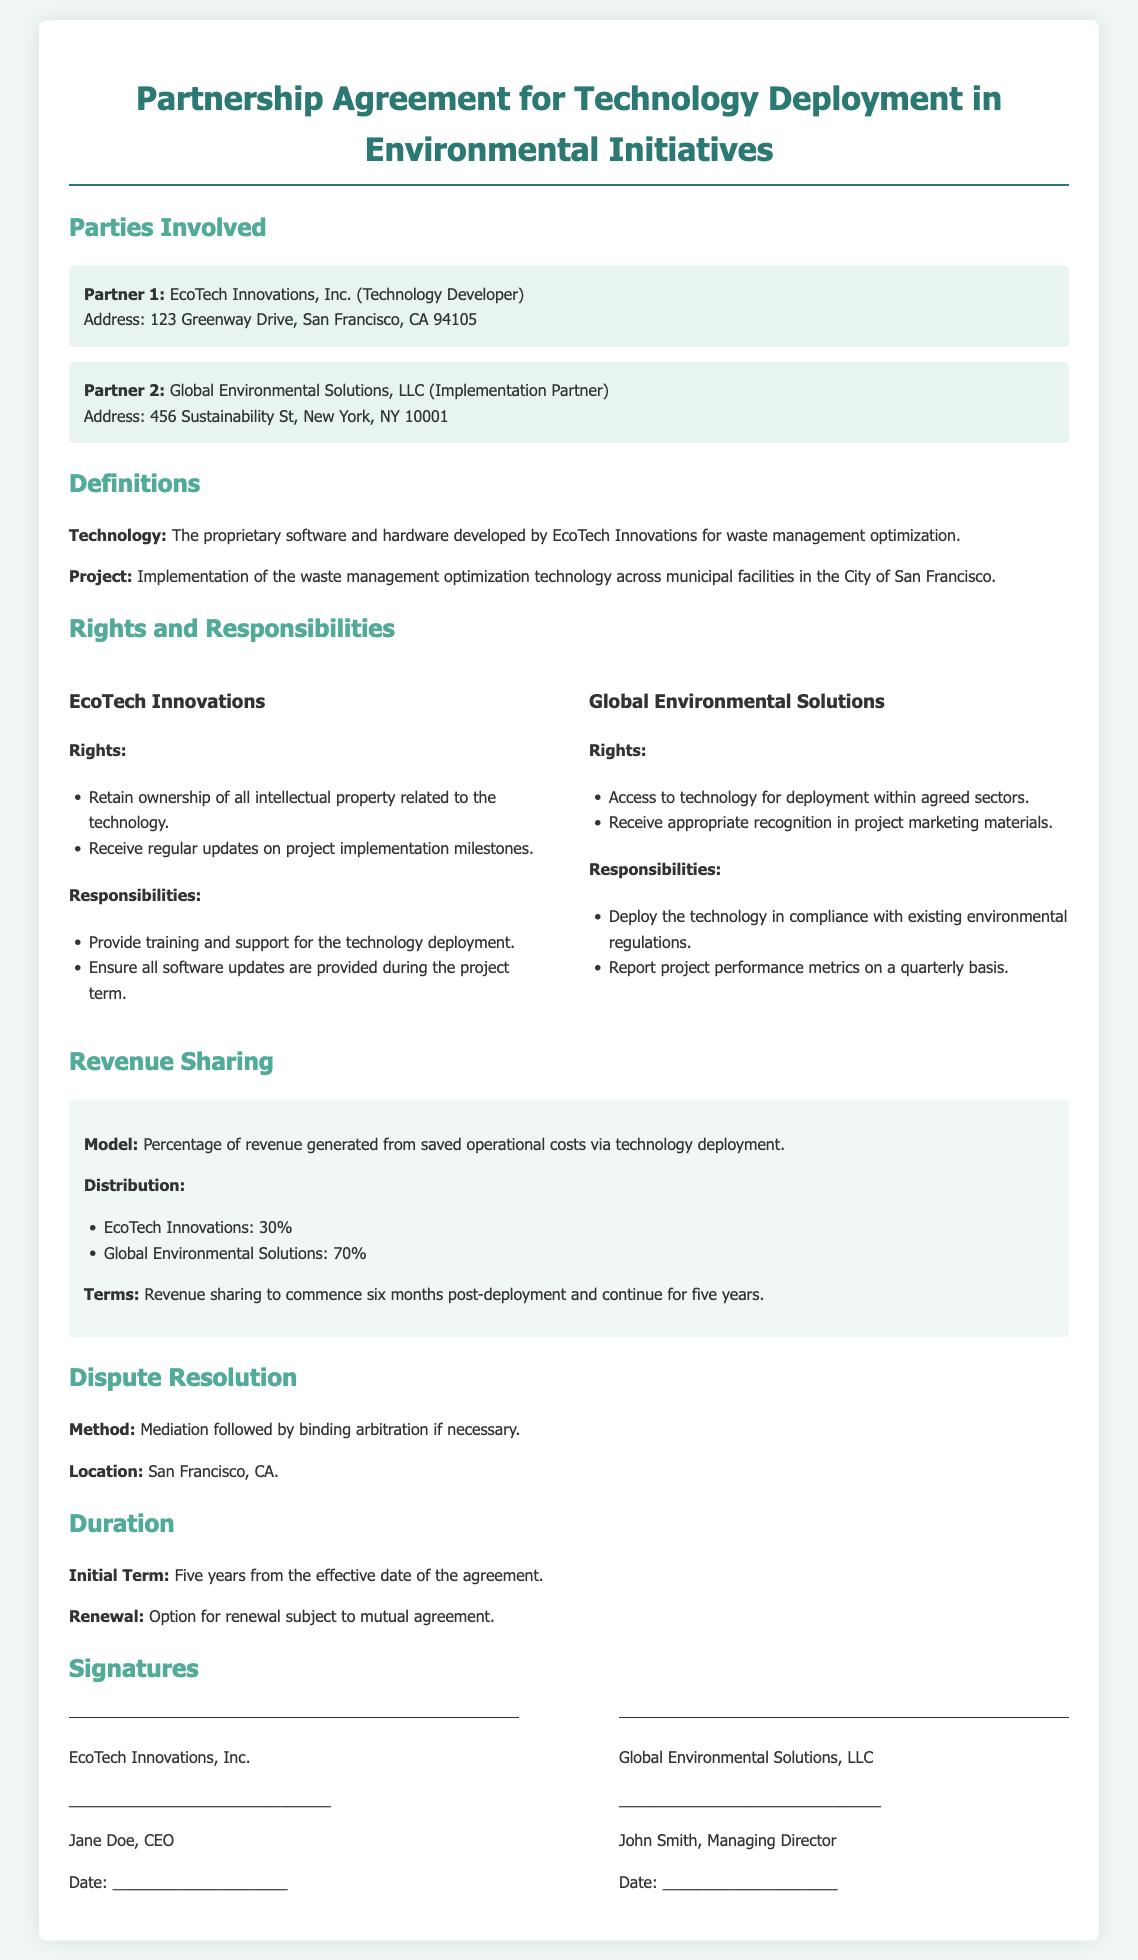What is the name of the technology developer? The document states that the technology developer is EcoTech Innovations, Inc.
Answer: EcoTech Innovations, Inc What is the project related to? The project involves the implementation of the waste management optimization technology across municipal facilities in the City of San Francisco.
Answer: Waste management optimization technology What is the revenue share percentage for Global Environmental Solutions? The revenue sharing distribution specifies that Global Environmental Solutions receives 70%.
Answer: 70% How long is the initial term of the agreement? The document indicates that the initial term of the agreement is five years.
Answer: Five years What method is used for dispute resolution? According to the document, the method for dispute resolution is mediation followed by binding arbitration if necessary.
Answer: Mediation What is one of the responsibilities of EcoTech Innovations? The document lists that EcoTech Innovations is responsible for providing training and support for the technology deployment.
Answer: Provide training and support What is the duration of the revenue-sharing terms after deployment? The revenue-sharing terms are stated to last for five years.
Answer: Five years Who is the CEO of EcoTech Innovations, Inc.? The document mentions that the CEO of EcoTech Innovations, Inc. is Jane Doe.
Answer: Jane Doe What is the address of Global Environmental Solutions, LLC? The address provided in the document for Global Environmental Solutions, LLC is 456 Sustainability St, New York, NY 10001.
Answer: 456 Sustainability St, New York, NY 10001 